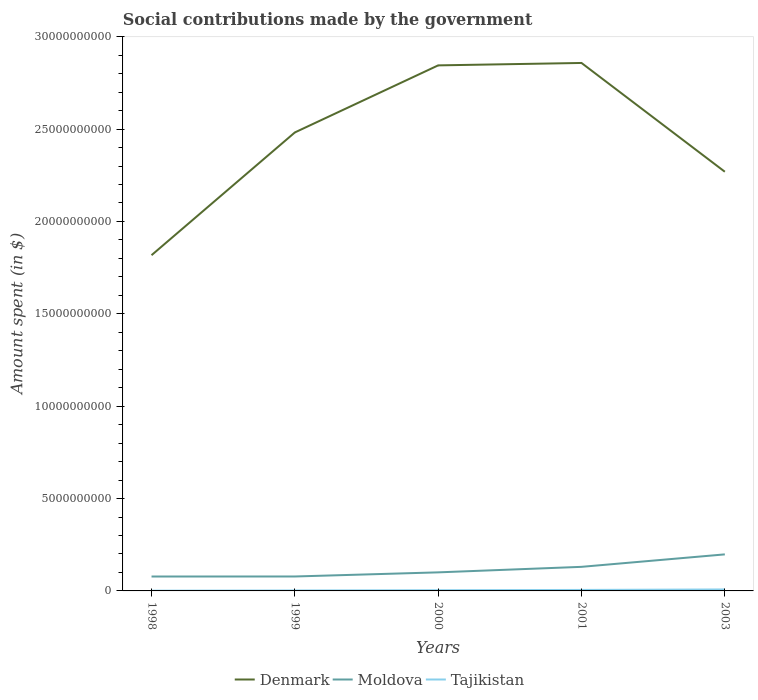How many different coloured lines are there?
Your answer should be compact. 3. Across all years, what is the maximum amount spent on social contributions in Denmark?
Keep it short and to the point. 1.82e+1. What is the total amount spent on social contributions in Moldova in the graph?
Your response must be concise. -1.20e+09. What is the difference between the highest and the second highest amount spent on social contributions in Tajikistan?
Your answer should be very brief. 6.65e+07. Does the graph contain any zero values?
Offer a very short reply. No. How many legend labels are there?
Ensure brevity in your answer.  3. What is the title of the graph?
Ensure brevity in your answer.  Social contributions made by the government. What is the label or title of the X-axis?
Give a very brief answer. Years. What is the label or title of the Y-axis?
Provide a succinct answer. Amount spent (in $). What is the Amount spent (in $) in Denmark in 1998?
Give a very brief answer. 1.82e+1. What is the Amount spent (in $) in Moldova in 1998?
Give a very brief answer. 7.80e+08. What is the Amount spent (in $) of Tajikistan in 1998?
Your answer should be very brief. 1.31e+07. What is the Amount spent (in $) in Denmark in 1999?
Your answer should be compact. 2.48e+1. What is the Amount spent (in $) of Moldova in 1999?
Keep it short and to the point. 7.81e+08. What is the Amount spent (in $) of Tajikistan in 1999?
Keep it short and to the point. 2.39e+07. What is the Amount spent (in $) in Denmark in 2000?
Make the answer very short. 2.84e+1. What is the Amount spent (in $) of Moldova in 2000?
Provide a short and direct response. 1.00e+09. What is the Amount spent (in $) in Tajikistan in 2000?
Provide a succinct answer. 3.81e+07. What is the Amount spent (in $) of Denmark in 2001?
Provide a succinct answer. 2.86e+1. What is the Amount spent (in $) in Moldova in 2001?
Give a very brief answer. 1.30e+09. What is the Amount spent (in $) of Tajikistan in 2001?
Your answer should be compact. 5.31e+07. What is the Amount spent (in $) of Denmark in 2003?
Make the answer very short. 2.27e+1. What is the Amount spent (in $) in Moldova in 2003?
Your answer should be very brief. 1.98e+09. What is the Amount spent (in $) of Tajikistan in 2003?
Keep it short and to the point. 7.96e+07. Across all years, what is the maximum Amount spent (in $) of Denmark?
Your answer should be very brief. 2.86e+1. Across all years, what is the maximum Amount spent (in $) of Moldova?
Ensure brevity in your answer.  1.98e+09. Across all years, what is the maximum Amount spent (in $) in Tajikistan?
Provide a succinct answer. 7.96e+07. Across all years, what is the minimum Amount spent (in $) of Denmark?
Ensure brevity in your answer.  1.82e+1. Across all years, what is the minimum Amount spent (in $) in Moldova?
Offer a terse response. 7.80e+08. Across all years, what is the minimum Amount spent (in $) in Tajikistan?
Your answer should be compact. 1.31e+07. What is the total Amount spent (in $) in Denmark in the graph?
Your answer should be very brief. 1.23e+11. What is the total Amount spent (in $) in Moldova in the graph?
Provide a short and direct response. 5.85e+09. What is the total Amount spent (in $) in Tajikistan in the graph?
Ensure brevity in your answer.  2.08e+08. What is the difference between the Amount spent (in $) of Denmark in 1998 and that in 1999?
Keep it short and to the point. -6.64e+09. What is the difference between the Amount spent (in $) in Moldova in 1998 and that in 1999?
Ensure brevity in your answer.  -1.70e+06. What is the difference between the Amount spent (in $) of Tajikistan in 1998 and that in 1999?
Provide a short and direct response. -1.07e+07. What is the difference between the Amount spent (in $) in Denmark in 1998 and that in 2000?
Ensure brevity in your answer.  -1.03e+1. What is the difference between the Amount spent (in $) of Moldova in 1998 and that in 2000?
Your answer should be compact. -2.26e+08. What is the difference between the Amount spent (in $) in Tajikistan in 1998 and that in 2000?
Your answer should be compact. -2.50e+07. What is the difference between the Amount spent (in $) of Denmark in 1998 and that in 2001?
Provide a short and direct response. -1.04e+1. What is the difference between the Amount spent (in $) in Moldova in 1998 and that in 2001?
Your answer should be compact. -5.24e+08. What is the difference between the Amount spent (in $) in Tajikistan in 1998 and that in 2001?
Provide a succinct answer. -4.00e+07. What is the difference between the Amount spent (in $) of Denmark in 1998 and that in 2003?
Your response must be concise. -4.52e+09. What is the difference between the Amount spent (in $) in Moldova in 1998 and that in 2003?
Give a very brief answer. -1.20e+09. What is the difference between the Amount spent (in $) in Tajikistan in 1998 and that in 2003?
Keep it short and to the point. -6.65e+07. What is the difference between the Amount spent (in $) of Denmark in 1999 and that in 2000?
Provide a short and direct response. -3.63e+09. What is the difference between the Amount spent (in $) of Moldova in 1999 and that in 2000?
Ensure brevity in your answer.  -2.24e+08. What is the difference between the Amount spent (in $) of Tajikistan in 1999 and that in 2000?
Your answer should be very brief. -1.43e+07. What is the difference between the Amount spent (in $) of Denmark in 1999 and that in 2001?
Ensure brevity in your answer.  -3.76e+09. What is the difference between the Amount spent (in $) in Moldova in 1999 and that in 2001?
Your answer should be compact. -5.22e+08. What is the difference between the Amount spent (in $) in Tajikistan in 1999 and that in 2001?
Provide a succinct answer. -2.93e+07. What is the difference between the Amount spent (in $) of Denmark in 1999 and that in 2003?
Ensure brevity in your answer.  2.13e+09. What is the difference between the Amount spent (in $) of Moldova in 1999 and that in 2003?
Provide a short and direct response. -1.20e+09. What is the difference between the Amount spent (in $) in Tajikistan in 1999 and that in 2003?
Offer a very short reply. -5.58e+07. What is the difference between the Amount spent (in $) in Denmark in 2000 and that in 2001?
Your response must be concise. -1.31e+08. What is the difference between the Amount spent (in $) of Moldova in 2000 and that in 2001?
Keep it short and to the point. -2.99e+08. What is the difference between the Amount spent (in $) of Tajikistan in 2000 and that in 2001?
Provide a short and direct response. -1.50e+07. What is the difference between the Amount spent (in $) of Denmark in 2000 and that in 2003?
Offer a terse response. 5.76e+09. What is the difference between the Amount spent (in $) of Moldova in 2000 and that in 2003?
Your answer should be compact. -9.73e+08. What is the difference between the Amount spent (in $) of Tajikistan in 2000 and that in 2003?
Provide a short and direct response. -4.15e+07. What is the difference between the Amount spent (in $) of Denmark in 2001 and that in 2003?
Provide a short and direct response. 5.89e+09. What is the difference between the Amount spent (in $) of Moldova in 2001 and that in 2003?
Keep it short and to the point. -6.74e+08. What is the difference between the Amount spent (in $) of Tajikistan in 2001 and that in 2003?
Make the answer very short. -2.65e+07. What is the difference between the Amount spent (in $) in Denmark in 1998 and the Amount spent (in $) in Moldova in 1999?
Keep it short and to the point. 1.74e+1. What is the difference between the Amount spent (in $) in Denmark in 1998 and the Amount spent (in $) in Tajikistan in 1999?
Keep it short and to the point. 1.81e+1. What is the difference between the Amount spent (in $) in Moldova in 1998 and the Amount spent (in $) in Tajikistan in 1999?
Provide a short and direct response. 7.56e+08. What is the difference between the Amount spent (in $) of Denmark in 1998 and the Amount spent (in $) of Moldova in 2000?
Provide a succinct answer. 1.72e+1. What is the difference between the Amount spent (in $) in Denmark in 1998 and the Amount spent (in $) in Tajikistan in 2000?
Your answer should be compact. 1.81e+1. What is the difference between the Amount spent (in $) in Moldova in 1998 and the Amount spent (in $) in Tajikistan in 2000?
Provide a succinct answer. 7.41e+08. What is the difference between the Amount spent (in $) in Denmark in 1998 and the Amount spent (in $) in Moldova in 2001?
Your answer should be compact. 1.69e+1. What is the difference between the Amount spent (in $) of Denmark in 1998 and the Amount spent (in $) of Tajikistan in 2001?
Offer a very short reply. 1.81e+1. What is the difference between the Amount spent (in $) in Moldova in 1998 and the Amount spent (in $) in Tajikistan in 2001?
Give a very brief answer. 7.26e+08. What is the difference between the Amount spent (in $) of Denmark in 1998 and the Amount spent (in $) of Moldova in 2003?
Give a very brief answer. 1.62e+1. What is the difference between the Amount spent (in $) of Denmark in 1998 and the Amount spent (in $) of Tajikistan in 2003?
Offer a very short reply. 1.81e+1. What is the difference between the Amount spent (in $) of Moldova in 1998 and the Amount spent (in $) of Tajikistan in 2003?
Your response must be concise. 7.00e+08. What is the difference between the Amount spent (in $) of Denmark in 1999 and the Amount spent (in $) of Moldova in 2000?
Keep it short and to the point. 2.38e+1. What is the difference between the Amount spent (in $) of Denmark in 1999 and the Amount spent (in $) of Tajikistan in 2000?
Offer a very short reply. 2.48e+1. What is the difference between the Amount spent (in $) in Moldova in 1999 and the Amount spent (in $) in Tajikistan in 2000?
Offer a very short reply. 7.43e+08. What is the difference between the Amount spent (in $) in Denmark in 1999 and the Amount spent (in $) in Moldova in 2001?
Make the answer very short. 2.35e+1. What is the difference between the Amount spent (in $) in Denmark in 1999 and the Amount spent (in $) in Tajikistan in 2001?
Provide a succinct answer. 2.48e+1. What is the difference between the Amount spent (in $) in Moldova in 1999 and the Amount spent (in $) in Tajikistan in 2001?
Make the answer very short. 7.28e+08. What is the difference between the Amount spent (in $) of Denmark in 1999 and the Amount spent (in $) of Moldova in 2003?
Make the answer very short. 2.28e+1. What is the difference between the Amount spent (in $) of Denmark in 1999 and the Amount spent (in $) of Tajikistan in 2003?
Give a very brief answer. 2.47e+1. What is the difference between the Amount spent (in $) of Moldova in 1999 and the Amount spent (in $) of Tajikistan in 2003?
Provide a succinct answer. 7.02e+08. What is the difference between the Amount spent (in $) of Denmark in 2000 and the Amount spent (in $) of Moldova in 2001?
Offer a very short reply. 2.71e+1. What is the difference between the Amount spent (in $) in Denmark in 2000 and the Amount spent (in $) in Tajikistan in 2001?
Provide a succinct answer. 2.84e+1. What is the difference between the Amount spent (in $) of Moldova in 2000 and the Amount spent (in $) of Tajikistan in 2001?
Provide a short and direct response. 9.52e+08. What is the difference between the Amount spent (in $) in Denmark in 2000 and the Amount spent (in $) in Moldova in 2003?
Offer a terse response. 2.65e+1. What is the difference between the Amount spent (in $) of Denmark in 2000 and the Amount spent (in $) of Tajikistan in 2003?
Keep it short and to the point. 2.84e+1. What is the difference between the Amount spent (in $) of Moldova in 2000 and the Amount spent (in $) of Tajikistan in 2003?
Keep it short and to the point. 9.25e+08. What is the difference between the Amount spent (in $) of Denmark in 2001 and the Amount spent (in $) of Moldova in 2003?
Offer a very short reply. 2.66e+1. What is the difference between the Amount spent (in $) in Denmark in 2001 and the Amount spent (in $) in Tajikistan in 2003?
Provide a succinct answer. 2.85e+1. What is the difference between the Amount spent (in $) of Moldova in 2001 and the Amount spent (in $) of Tajikistan in 2003?
Give a very brief answer. 1.22e+09. What is the average Amount spent (in $) in Denmark per year?
Your response must be concise. 2.45e+1. What is the average Amount spent (in $) of Moldova per year?
Give a very brief answer. 1.17e+09. What is the average Amount spent (in $) of Tajikistan per year?
Provide a short and direct response. 4.16e+07. In the year 1998, what is the difference between the Amount spent (in $) of Denmark and Amount spent (in $) of Moldova?
Provide a short and direct response. 1.74e+1. In the year 1998, what is the difference between the Amount spent (in $) of Denmark and Amount spent (in $) of Tajikistan?
Provide a succinct answer. 1.82e+1. In the year 1998, what is the difference between the Amount spent (in $) in Moldova and Amount spent (in $) in Tajikistan?
Provide a short and direct response. 7.66e+08. In the year 1999, what is the difference between the Amount spent (in $) in Denmark and Amount spent (in $) in Moldova?
Offer a terse response. 2.40e+1. In the year 1999, what is the difference between the Amount spent (in $) of Denmark and Amount spent (in $) of Tajikistan?
Your answer should be very brief. 2.48e+1. In the year 1999, what is the difference between the Amount spent (in $) in Moldova and Amount spent (in $) in Tajikistan?
Provide a short and direct response. 7.57e+08. In the year 2000, what is the difference between the Amount spent (in $) in Denmark and Amount spent (in $) in Moldova?
Offer a terse response. 2.74e+1. In the year 2000, what is the difference between the Amount spent (in $) in Denmark and Amount spent (in $) in Tajikistan?
Your answer should be compact. 2.84e+1. In the year 2000, what is the difference between the Amount spent (in $) in Moldova and Amount spent (in $) in Tajikistan?
Offer a terse response. 9.67e+08. In the year 2001, what is the difference between the Amount spent (in $) of Denmark and Amount spent (in $) of Moldova?
Your answer should be very brief. 2.73e+1. In the year 2001, what is the difference between the Amount spent (in $) in Denmark and Amount spent (in $) in Tajikistan?
Provide a short and direct response. 2.85e+1. In the year 2001, what is the difference between the Amount spent (in $) in Moldova and Amount spent (in $) in Tajikistan?
Your response must be concise. 1.25e+09. In the year 2003, what is the difference between the Amount spent (in $) of Denmark and Amount spent (in $) of Moldova?
Offer a very short reply. 2.07e+1. In the year 2003, what is the difference between the Amount spent (in $) in Denmark and Amount spent (in $) in Tajikistan?
Offer a very short reply. 2.26e+1. In the year 2003, what is the difference between the Amount spent (in $) in Moldova and Amount spent (in $) in Tajikistan?
Your answer should be very brief. 1.90e+09. What is the ratio of the Amount spent (in $) in Denmark in 1998 to that in 1999?
Offer a terse response. 0.73. What is the ratio of the Amount spent (in $) in Tajikistan in 1998 to that in 1999?
Provide a succinct answer. 0.55. What is the ratio of the Amount spent (in $) in Denmark in 1998 to that in 2000?
Keep it short and to the point. 0.64. What is the ratio of the Amount spent (in $) of Moldova in 1998 to that in 2000?
Offer a very short reply. 0.78. What is the ratio of the Amount spent (in $) of Tajikistan in 1998 to that in 2000?
Your response must be concise. 0.34. What is the ratio of the Amount spent (in $) in Denmark in 1998 to that in 2001?
Your answer should be very brief. 0.64. What is the ratio of the Amount spent (in $) of Moldova in 1998 to that in 2001?
Ensure brevity in your answer.  0.6. What is the ratio of the Amount spent (in $) in Tajikistan in 1998 to that in 2001?
Make the answer very short. 0.25. What is the ratio of the Amount spent (in $) in Denmark in 1998 to that in 2003?
Ensure brevity in your answer.  0.8. What is the ratio of the Amount spent (in $) in Moldova in 1998 to that in 2003?
Provide a short and direct response. 0.39. What is the ratio of the Amount spent (in $) of Tajikistan in 1998 to that in 2003?
Your answer should be compact. 0.16. What is the ratio of the Amount spent (in $) in Denmark in 1999 to that in 2000?
Your answer should be very brief. 0.87. What is the ratio of the Amount spent (in $) in Moldova in 1999 to that in 2000?
Your answer should be very brief. 0.78. What is the ratio of the Amount spent (in $) in Tajikistan in 1999 to that in 2000?
Offer a very short reply. 0.63. What is the ratio of the Amount spent (in $) of Denmark in 1999 to that in 2001?
Offer a terse response. 0.87. What is the ratio of the Amount spent (in $) of Moldova in 1999 to that in 2001?
Ensure brevity in your answer.  0.6. What is the ratio of the Amount spent (in $) of Tajikistan in 1999 to that in 2001?
Give a very brief answer. 0.45. What is the ratio of the Amount spent (in $) of Denmark in 1999 to that in 2003?
Ensure brevity in your answer.  1.09. What is the ratio of the Amount spent (in $) of Moldova in 1999 to that in 2003?
Offer a terse response. 0.39. What is the ratio of the Amount spent (in $) in Tajikistan in 1999 to that in 2003?
Ensure brevity in your answer.  0.3. What is the ratio of the Amount spent (in $) in Moldova in 2000 to that in 2001?
Your answer should be compact. 0.77. What is the ratio of the Amount spent (in $) in Tajikistan in 2000 to that in 2001?
Your answer should be compact. 0.72. What is the ratio of the Amount spent (in $) in Denmark in 2000 to that in 2003?
Offer a very short reply. 1.25. What is the ratio of the Amount spent (in $) of Moldova in 2000 to that in 2003?
Make the answer very short. 0.51. What is the ratio of the Amount spent (in $) of Tajikistan in 2000 to that in 2003?
Keep it short and to the point. 0.48. What is the ratio of the Amount spent (in $) in Denmark in 2001 to that in 2003?
Offer a very short reply. 1.26. What is the ratio of the Amount spent (in $) of Moldova in 2001 to that in 2003?
Ensure brevity in your answer.  0.66. What is the ratio of the Amount spent (in $) of Tajikistan in 2001 to that in 2003?
Offer a very short reply. 0.67. What is the difference between the highest and the second highest Amount spent (in $) in Denmark?
Your answer should be compact. 1.31e+08. What is the difference between the highest and the second highest Amount spent (in $) of Moldova?
Make the answer very short. 6.74e+08. What is the difference between the highest and the second highest Amount spent (in $) in Tajikistan?
Make the answer very short. 2.65e+07. What is the difference between the highest and the lowest Amount spent (in $) in Denmark?
Provide a succinct answer. 1.04e+1. What is the difference between the highest and the lowest Amount spent (in $) in Moldova?
Provide a short and direct response. 1.20e+09. What is the difference between the highest and the lowest Amount spent (in $) in Tajikistan?
Ensure brevity in your answer.  6.65e+07. 